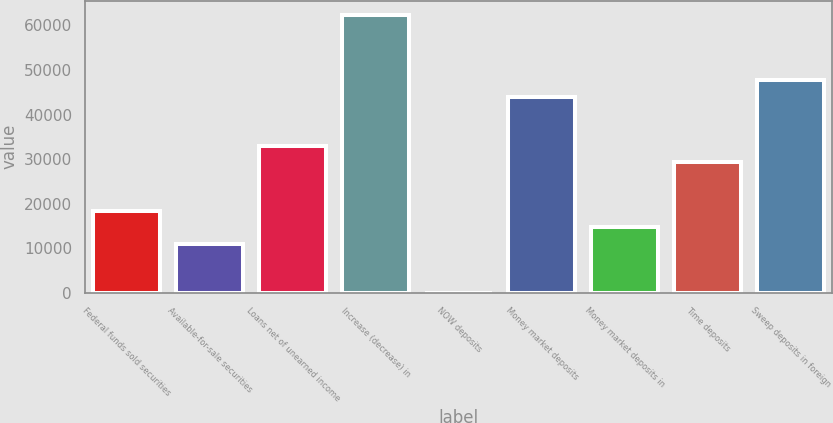<chart> <loc_0><loc_0><loc_500><loc_500><bar_chart><fcel>Federal funds sold securities<fcel>Available-for-sale securities<fcel>Loans net of unearned income<fcel>Increase (decrease) in<fcel>NOW deposits<fcel>Money market deposits<fcel>Money market deposits in<fcel>Time deposits<fcel>Sweep deposits in foreign<nl><fcel>18355<fcel>11017.4<fcel>33030.2<fcel>62380.6<fcel>11<fcel>44036.6<fcel>14686.2<fcel>29361.4<fcel>47705.4<nl></chart> 